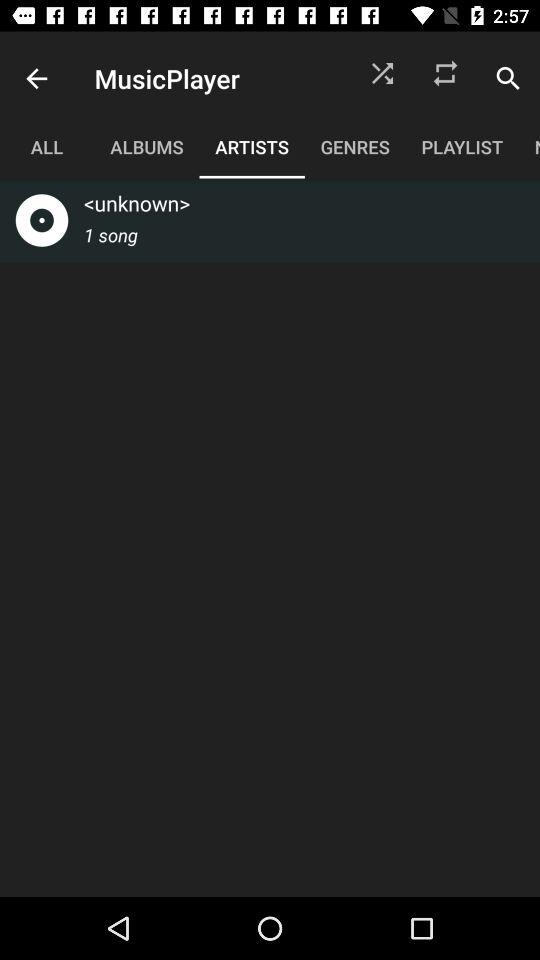Which tab is selected? The selected tab is "ARTISTS". 